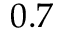Convert formula to latex. <formula><loc_0><loc_0><loc_500><loc_500>0 . 7</formula> 